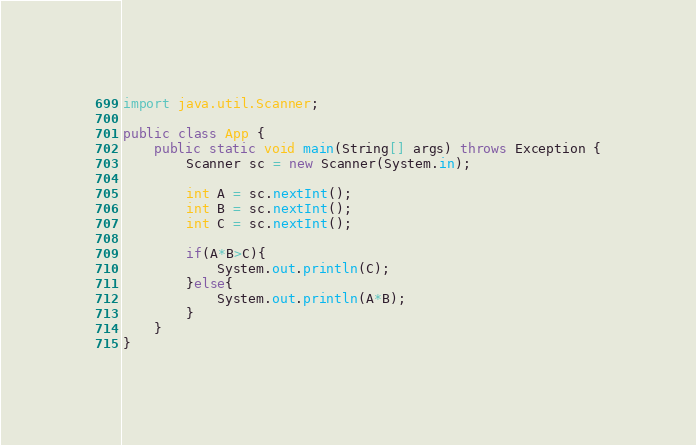Convert code to text. <code><loc_0><loc_0><loc_500><loc_500><_Java_>import java.util.Scanner;

public class App {
    public static void main(String[] args) throws Exception {
        Scanner sc = new Scanner(System.in);

        int A = sc.nextInt();
        int B = sc.nextInt();
        int C = sc.nextInt();

        if(A*B>C){          
            System.out.println(C);  
        }else{
            System.out.println(A*B);
        }        
    }
}</code> 